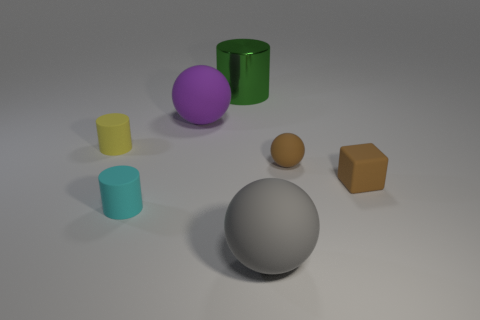Subtract all large balls. How many balls are left? 1 Add 3 tiny matte cylinders. How many objects exist? 10 Subtract all yellow cylinders. How many cylinders are left? 2 Subtract all red cylinders. Subtract all cyan cubes. How many cylinders are left? 3 Subtract all balls. How many objects are left? 4 Add 1 large yellow rubber objects. How many large yellow rubber objects exist? 1 Subtract 1 brown cubes. How many objects are left? 6 Subtract all tiny cyan shiny things. Subtract all yellow cylinders. How many objects are left? 6 Add 5 cyan matte cylinders. How many cyan matte cylinders are left? 6 